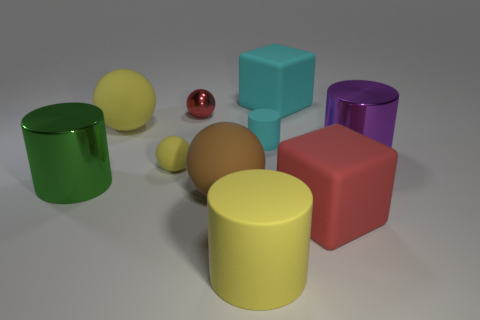Subtract all big green metallic cylinders. How many cylinders are left? 3 Subtract all balls. How many objects are left? 6 Subtract 4 spheres. How many spheres are left? 0 Subtract all brown balls. How many balls are left? 3 Subtract all tiny metallic balls. Subtract all large brown balls. How many objects are left? 8 Add 1 small red shiny things. How many small red shiny things are left? 2 Add 3 blue blocks. How many blue blocks exist? 3 Subtract 1 brown spheres. How many objects are left? 9 Subtract all gray cubes. Subtract all brown balls. How many cubes are left? 2 Subtract all green spheres. How many yellow cylinders are left? 1 